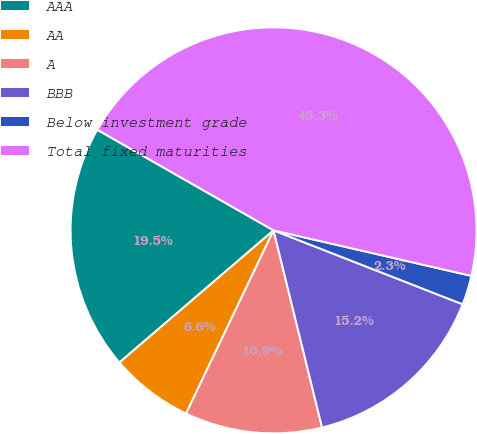<chart> <loc_0><loc_0><loc_500><loc_500><pie_chart><fcel>AAA<fcel>AA<fcel>A<fcel>BBB<fcel>Below investment grade<fcel>Total fixed maturities<nl><fcel>19.53%<fcel>6.63%<fcel>10.93%<fcel>15.23%<fcel>2.33%<fcel>45.34%<nl></chart> 